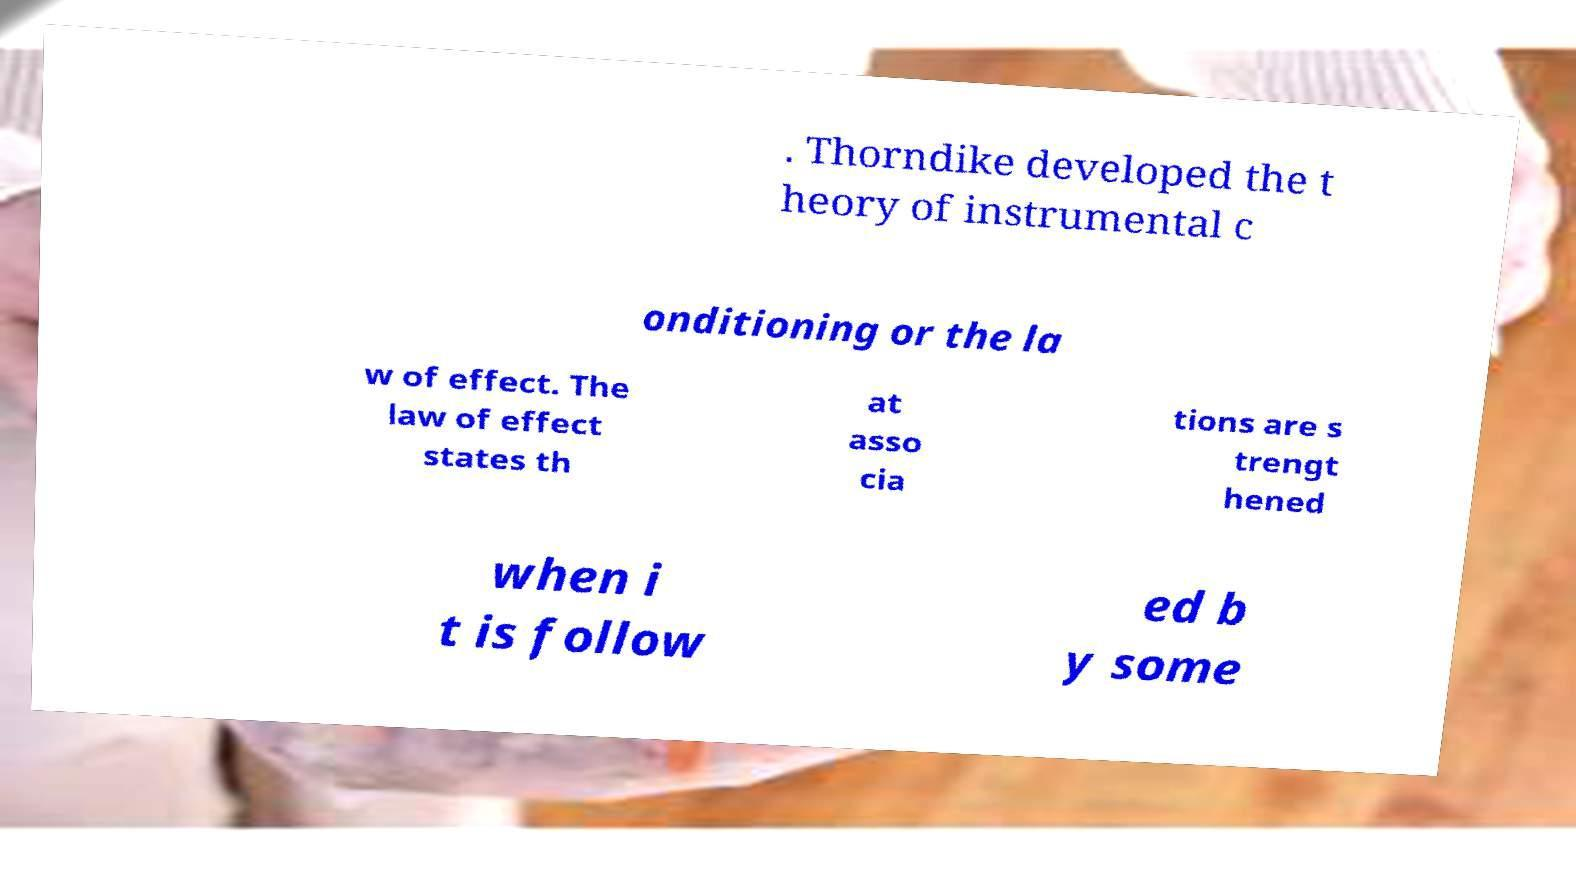There's text embedded in this image that I need extracted. Can you transcribe it verbatim? . Thorndike developed the t heory of instrumental c onditioning or the la w of effect. The law of effect states th at asso cia tions are s trengt hened when i t is follow ed b y some 